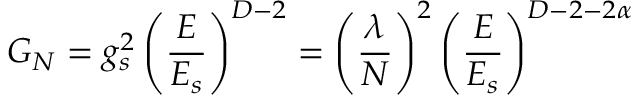<formula> <loc_0><loc_0><loc_500><loc_500>G _ { N } = g _ { s } ^ { 2 } \left ( { \frac { E } { E _ { s } } } \right ) ^ { D - 2 } = \left ( { \frac { \lambda } { N } } \right ) ^ { 2 } \left ( { \frac { E } { E _ { s } } } \right ) ^ { D - 2 - 2 \alpha }</formula> 